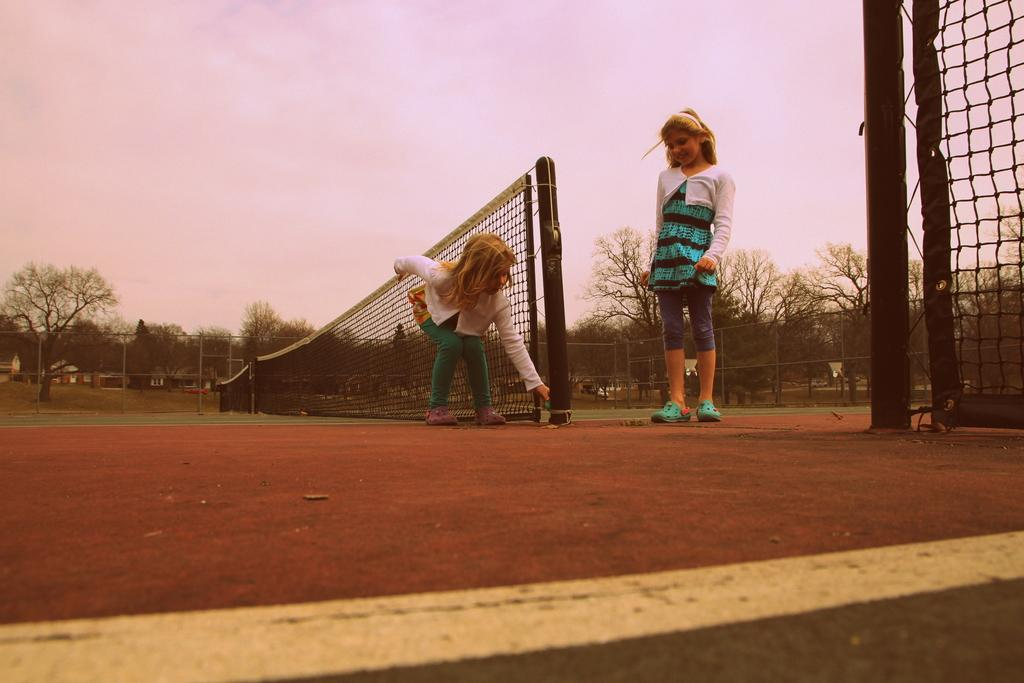What type of sports facility is shown in the image? There are tennis courts in the image. What is used to divide the tennis courts in the image? There are nets in the image. What natural elements can be seen in the image? There are trees in the image. What type of barrier is present in the image? There is fencing in the image. What marking is visible on the tennis courts in the image? There is a white line visible in the image. How many people are present in the image? There are two girls in the image. What type of silver object can be seen in the hands of the girls in the image? There is no silver object visible in the hands of the girls in the image. What type of judge is present in the image? There is no judge present in the image; it features tennis courts and two girls. 